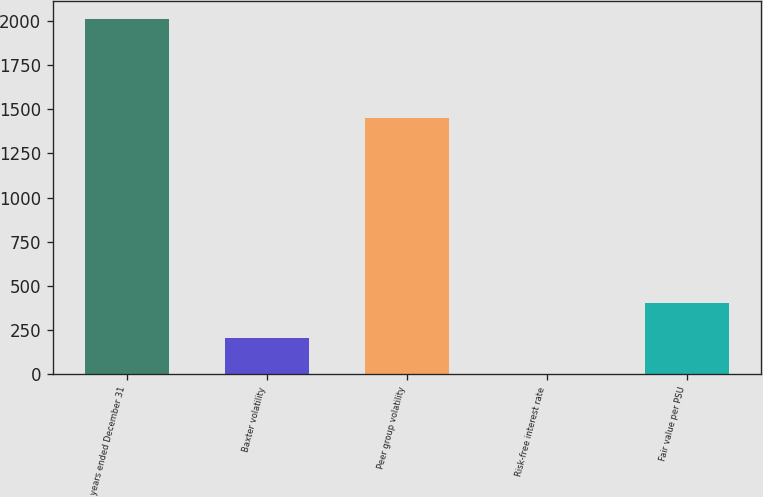<chart> <loc_0><loc_0><loc_500><loc_500><bar_chart><fcel>years ended December 31<fcel>Baxter volatility<fcel>Peer group volatility<fcel>Risk-free interest rate<fcel>Fair value per PSU<nl><fcel>2012<fcel>201.56<fcel>1450<fcel>0.4<fcel>402.72<nl></chart> 